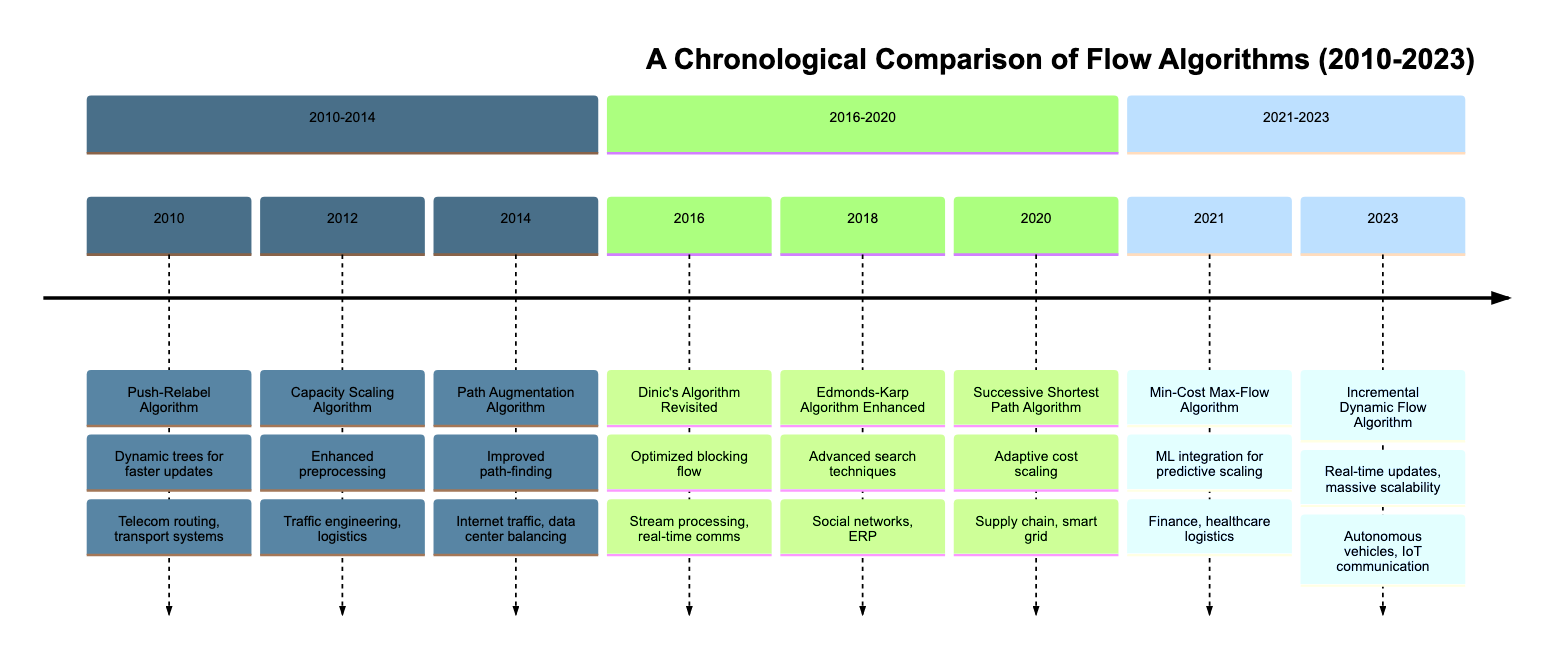What algorithm was introduced in 2010? The diagram indicates that the Push-Relabel Algorithm was the first algorithm introduced in the year 2010, as per the corresponding section.
Answer: Push-Relabel Algorithm Which algorithm enhanced in 2018 focused on social networks? Referring to the 2018 section in the diagram, the Edmonds-Karp Algorithm Enhanced is mentioned with applications that include social networks.
Answer: Edmonds-Karp Algorithm Enhanced What year did the Incremental Dynamic Flow Algorithm debut? By locating the last section of the timeline, the diagram specifies that the Incremental Dynamic Flow Algorithm was introduced in 2023.
Answer: 2023 Which algorithm introduced in 2020 is applied to smart grid optimization? According to the timeline, the Successive Shortest Path Algorithm is specifically noted to be applicable for smart grid optimization and was introduced in 2020.
Answer: Successive Shortest Path Algorithm What efficiency improvement was made for the Capacity Scaling Algorithm in 2012? The diagram states that the Capacity Scaling Algorithm saw enhanced preprocessing for capacity updates in 2012. By analyzing this particular section, we can confirm this improvement.
Answer: Enhanced preprocessing Which two algorithms focus on real-time applications? The diagram highlights Dinic's Algorithm Revisited (2016) for stream processing and real-time communication networks, and the Incremental Dynamic Flow Algorithm (2023) for IoT device communication, indicating their related applications.
Answer: Dinic's Algorithm Revisited, Incremental Dynamic Flow Algorithm How many algorithms were introduced between 2010 and 2014? Evaluating the diagram section from 2010 to 2014 reveals three algorithms: Push-Relabel (2010), Capacity Scaling (2012), and Path Augmentation (2014). Counting these gives us the answer.
Answer: 3 What did the 2021 algorithm integrate with to enhance its capabilities? The diagram indicates that the Min-Cost Max-Flow Algorithm introduced in 2021 integrated with machine learning models for predictive scaling, specifically stated in its section.
Answer: Machine learning models Which algorithm included a reduction in bottleneck issues? In the timeline, the Successive Shortest Path Algorithm (2020) is described as having reduced bottleneck issues through adaptive cost scaling, thus answering the inquiry about the specific algorithm.
Answer: Successive Shortest Path Algorithm 